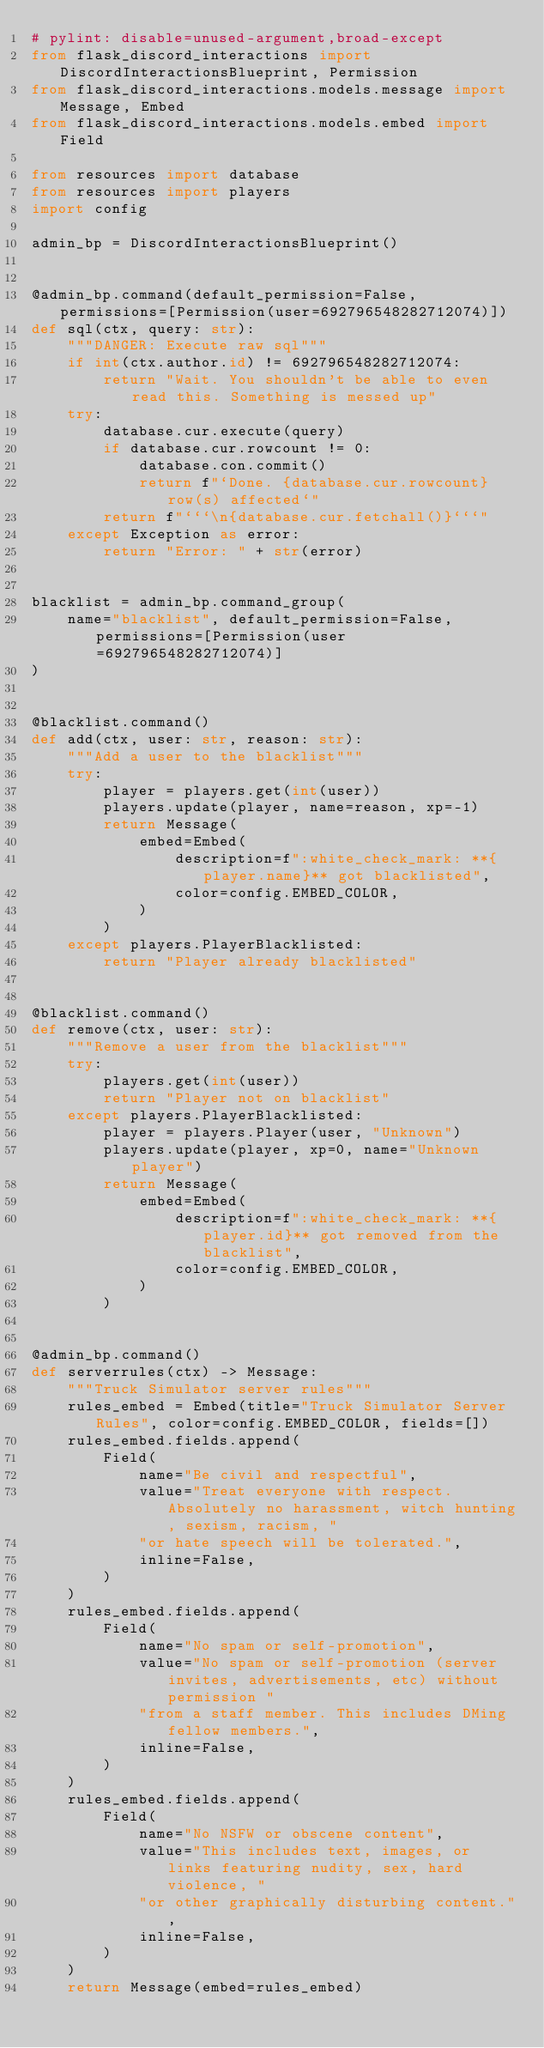<code> <loc_0><loc_0><loc_500><loc_500><_Python_># pylint: disable=unused-argument,broad-except
from flask_discord_interactions import DiscordInteractionsBlueprint, Permission
from flask_discord_interactions.models.message import Message, Embed
from flask_discord_interactions.models.embed import Field

from resources import database
from resources import players
import config

admin_bp = DiscordInteractionsBlueprint()


@admin_bp.command(default_permission=False, permissions=[Permission(user=692796548282712074)])
def sql(ctx, query: str):
    """DANGER: Execute raw sql"""
    if int(ctx.author.id) != 692796548282712074:
        return "Wait. You shouldn't be able to even read this. Something is messed up"
    try:
        database.cur.execute(query)
        if database.cur.rowcount != 0:
            database.con.commit()
            return f"`Done. {database.cur.rowcount} row(s) affected`"
        return f"```\n{database.cur.fetchall()}```"
    except Exception as error:
        return "Error: " + str(error)


blacklist = admin_bp.command_group(
    name="blacklist", default_permission=False, permissions=[Permission(user=692796548282712074)]
)


@blacklist.command()
def add(ctx, user: str, reason: str):
    """Add a user to the blacklist"""
    try:
        player = players.get(int(user))
        players.update(player, name=reason, xp=-1)
        return Message(
            embed=Embed(
                description=f":white_check_mark: **{player.name}** got blacklisted",
                color=config.EMBED_COLOR,
            )
        )
    except players.PlayerBlacklisted:
        return "Player already blacklisted"


@blacklist.command()
def remove(ctx, user: str):
    """Remove a user from the blacklist"""
    try:
        players.get(int(user))
        return "Player not on blacklist"
    except players.PlayerBlacklisted:
        player = players.Player(user, "Unknown")
        players.update(player, xp=0, name="Unknown player")
        return Message(
            embed=Embed(
                description=f":white_check_mark: **{player.id}** got removed from the blacklist",
                color=config.EMBED_COLOR,
            )
        )


@admin_bp.command()
def serverrules(ctx) -> Message:
    """Truck Simulator server rules"""
    rules_embed = Embed(title="Truck Simulator Server Rules", color=config.EMBED_COLOR, fields=[])
    rules_embed.fields.append(
        Field(
            name="Be civil and respectful",
            value="Treat everyone with respect. Absolutely no harassment, witch hunting, sexism, racism, "
            "or hate speech will be tolerated.",
            inline=False,
        )
    )
    rules_embed.fields.append(
        Field(
            name="No spam or self-promotion",
            value="No spam or self-promotion (server invites, advertisements, etc) without permission "
            "from a staff member. This includes DMing fellow members.",
            inline=False,
        )
    )
    rules_embed.fields.append(
        Field(
            name="No NSFW or obscene content",
            value="This includes text, images, or links featuring nudity, sex, hard violence, "
            "or other graphically disturbing content.",
            inline=False,
        )
    )
    return Message(embed=rules_embed)
</code> 